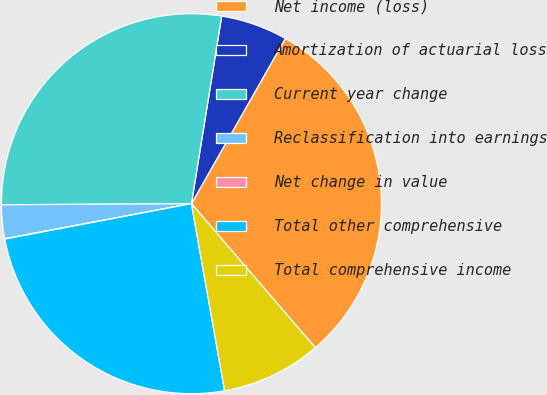Convert chart to OTSL. <chart><loc_0><loc_0><loc_500><loc_500><pie_chart><fcel>Net income (loss)<fcel>Amortization of actuarial loss<fcel>Current year change<fcel>Reclassification into earnings<fcel>Net change in value<fcel>Total other comprehensive<fcel>Total comprehensive income<nl><fcel>30.47%<fcel>5.68%<fcel>27.64%<fcel>2.86%<fcel>0.03%<fcel>24.81%<fcel>8.51%<nl></chart> 